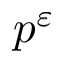Convert formula to latex. <formula><loc_0><loc_0><loc_500><loc_500>p ^ { \varepsilon }</formula> 